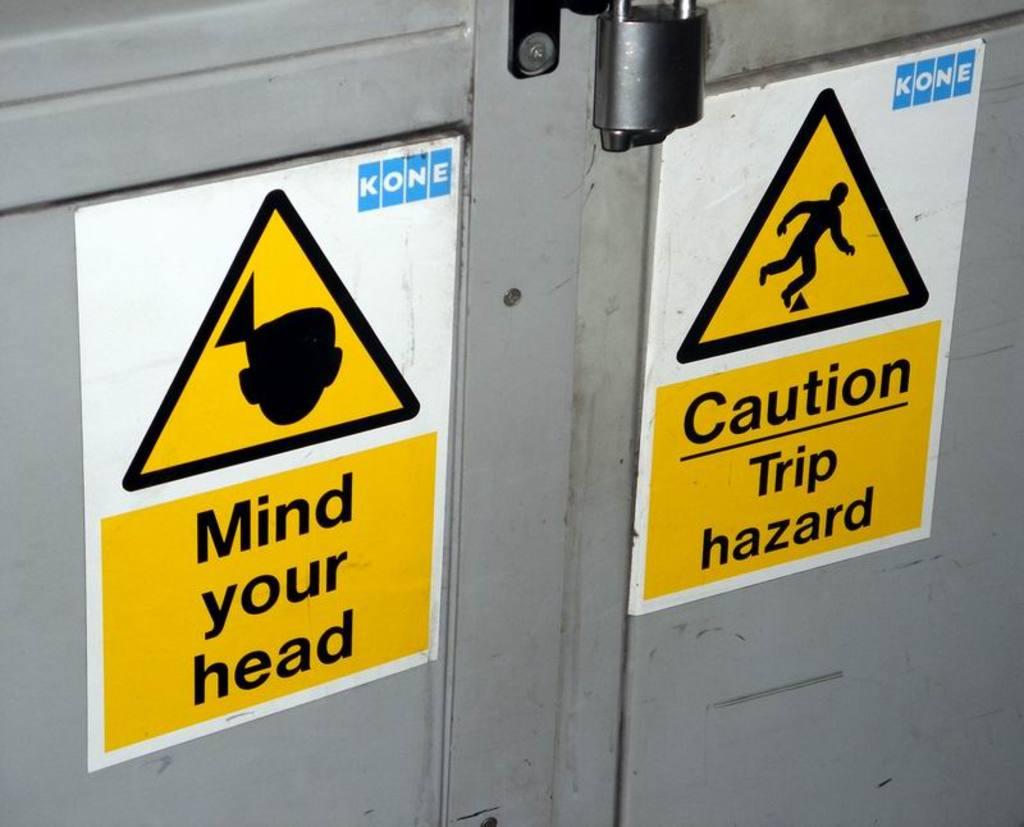What does the caution sign warn you about?
Your answer should be very brief. Trip hazard. Which body part can be injured?
Your answer should be very brief. Head. 